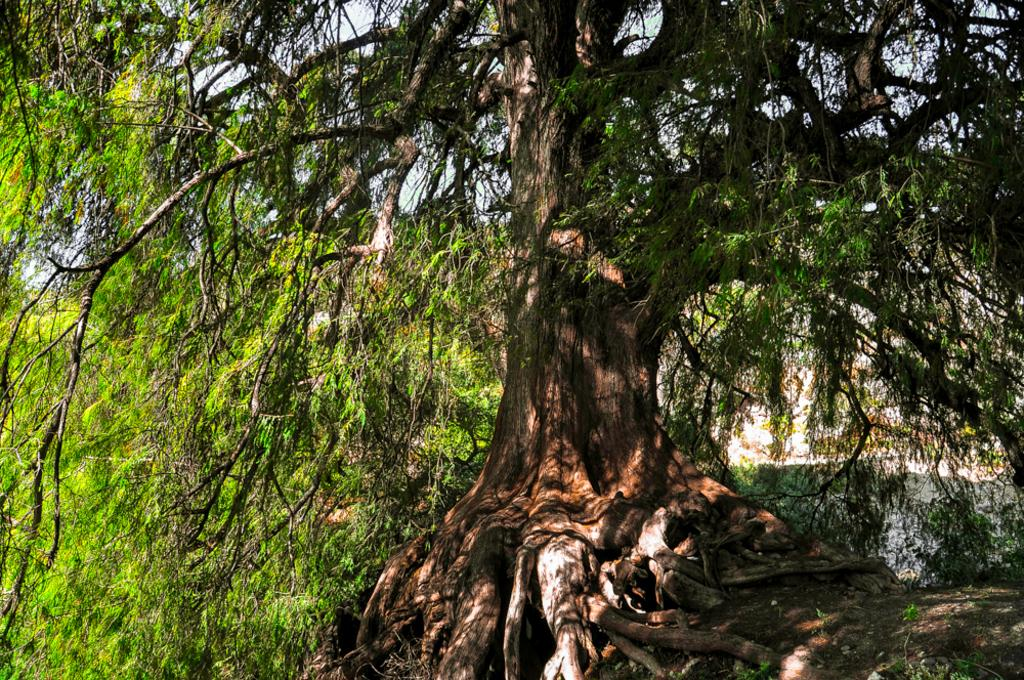What type of vegetation is present in the image? There are trees in the front of the image. What part of the natural environment is visible in the image? The sky is visible in the background of the image. What type of club is visible in the image? There is no club present in the image; it features trees and the sky. 